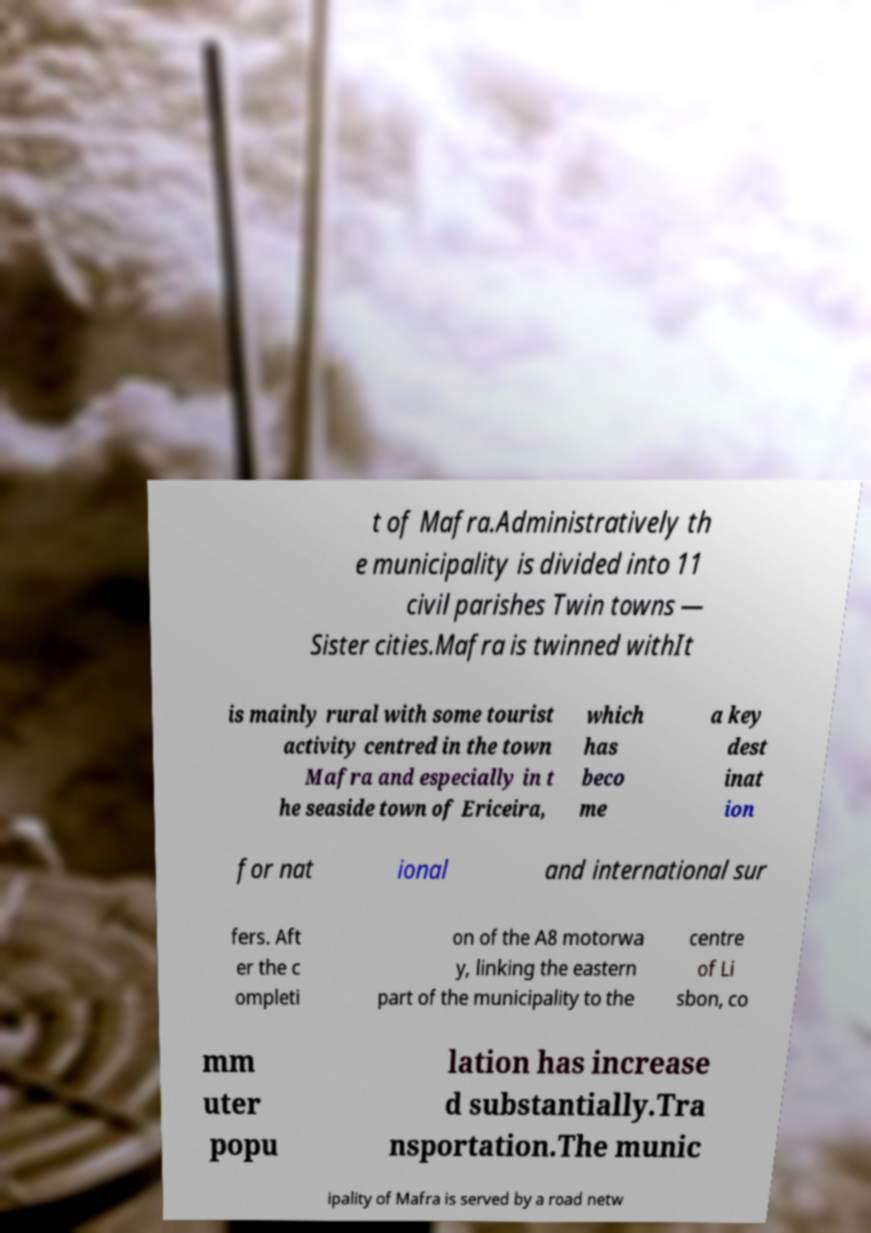Could you assist in decoding the text presented in this image and type it out clearly? t of Mafra.Administratively th e municipality is divided into 11 civil parishes Twin towns — Sister cities.Mafra is twinned withIt is mainly rural with some tourist activity centred in the town Mafra and especially in t he seaside town of Ericeira, which has beco me a key dest inat ion for nat ional and international sur fers. Aft er the c ompleti on of the A8 motorwa y, linking the eastern part of the municipality to the centre of Li sbon, co mm uter popu lation has increase d substantially.Tra nsportation.The munic ipality of Mafra is served by a road netw 